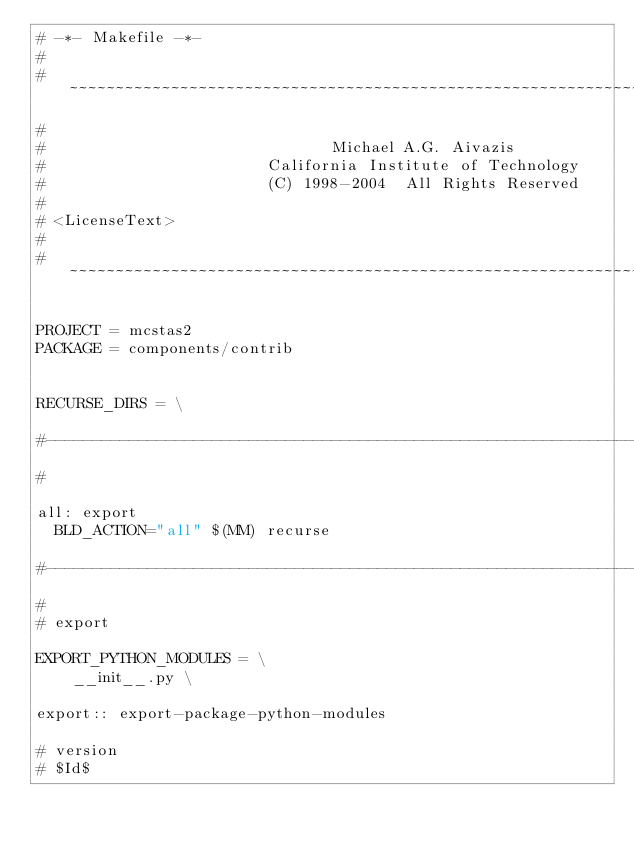<code> <loc_0><loc_0><loc_500><loc_500><_ObjectiveC_># -*- Makefile -*-
#
# ~~~~~~~~~~~~~~~~~~~~~~~~~~~~~~~~~~~~~~~~~~~~~~~~~~~~~~~~~~~~~~~~~~~~~~~~~~~~~~~~
#
#                               Michael A.G. Aivazis
#                        California Institute of Technology
#                        (C) 1998-2004  All Rights Reserved
#
# <LicenseText>
#
# ~~~~~~~~~~~~~~~~~~~~~~~~~~~~~~~~~~~~~~~~~~~~~~~~~~~~~~~~~~~~~~~~~~~~~~~~~~~~~~~~

PROJECT = mcstas2
PACKAGE = components/contrib


RECURSE_DIRS = \

#--------------------------------------------------------------------------
#

all: export
	BLD_ACTION="all" $(MM) recurse

#--------------------------------------------------------------------------
#
# export

EXPORT_PYTHON_MODULES = \
    __init__.py \

export:: export-package-python-modules

# version
# $Id$
</code> 